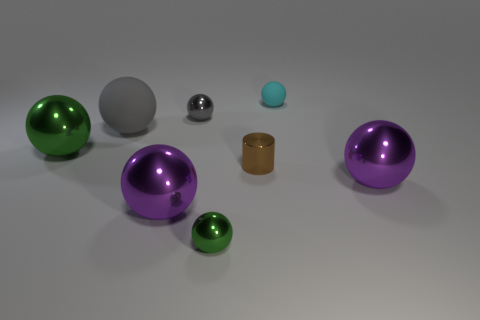There is a gray rubber ball; are there any small shiny objects in front of it?
Offer a terse response. Yes. What number of other things are there of the same size as the cyan matte ball?
Provide a short and direct response. 3. What is the small object that is both behind the cylinder and to the right of the tiny gray metal thing made of?
Give a very brief answer. Rubber. Do the purple object on the left side of the brown object and the green thing that is behind the tiny green metal ball have the same shape?
Provide a short and direct response. Yes. The green object that is in front of the purple thing that is to the right of the tiny green metallic thing that is left of the brown shiny object is what shape?
Provide a short and direct response. Sphere. What number of other things are the same shape as the gray rubber object?
Your answer should be very brief. 6. There is a shiny cylinder that is the same size as the gray metal ball; what color is it?
Your response must be concise. Brown. What number of cubes are tiny gray shiny things or cyan matte objects?
Your answer should be compact. 0. How many brown metal cylinders are there?
Offer a very short reply. 1. Is the shape of the large gray thing the same as the metallic object that is right of the small brown metallic cylinder?
Make the answer very short. Yes. 